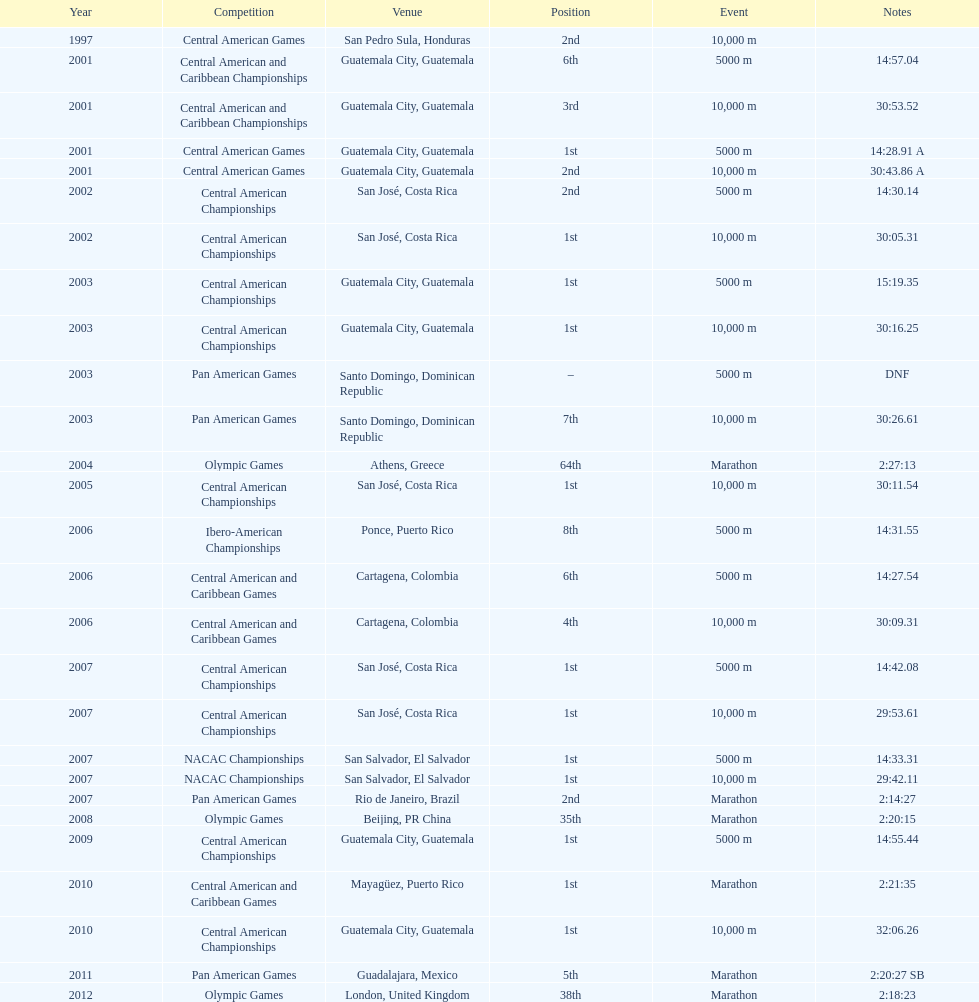What event did this participant enter after the 2001 central american games? Central American Championships. 